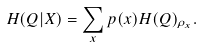<formula> <loc_0><loc_0><loc_500><loc_500>H ( Q | X ) = \sum _ { x } p ( x ) H ( Q ) _ { \rho _ { x } } .</formula> 